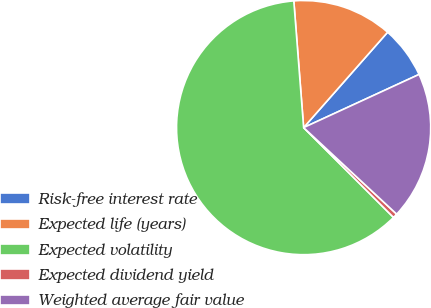Convert chart. <chart><loc_0><loc_0><loc_500><loc_500><pie_chart><fcel>Risk-free interest rate<fcel>Expected life (years)<fcel>Expected volatility<fcel>Expected dividend yield<fcel>Weighted average fair value<nl><fcel>6.64%<fcel>12.72%<fcel>61.27%<fcel>0.57%<fcel>18.79%<nl></chart> 